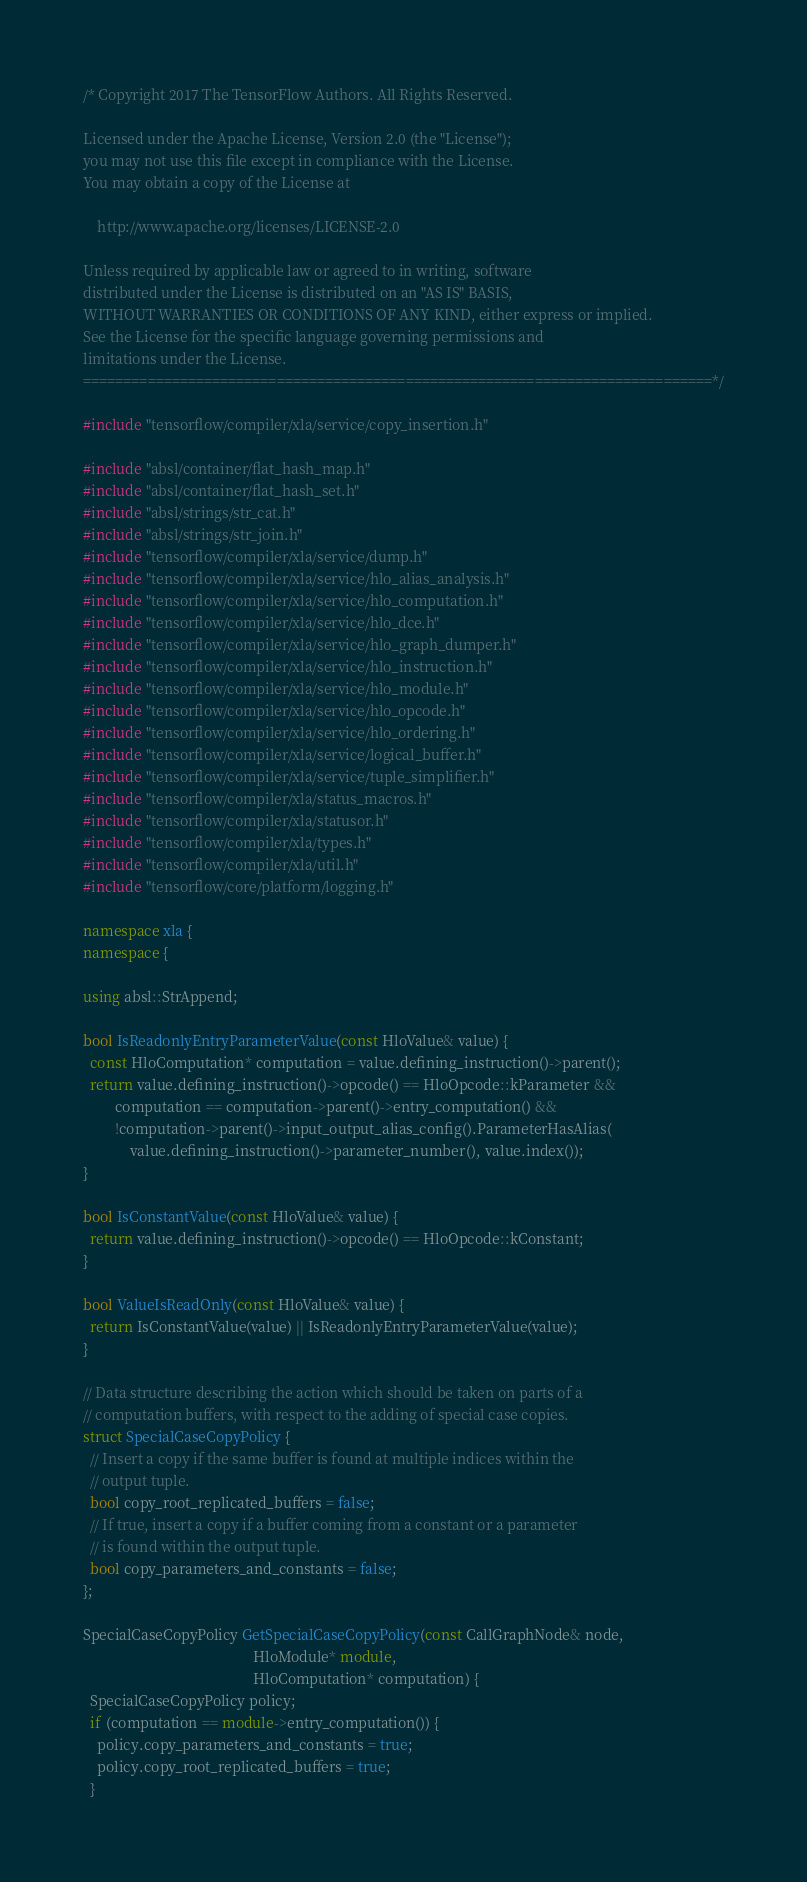<code> <loc_0><loc_0><loc_500><loc_500><_C++_>/* Copyright 2017 The TensorFlow Authors. All Rights Reserved.

Licensed under the Apache License, Version 2.0 (the "License");
you may not use this file except in compliance with the License.
You may obtain a copy of the License at

    http://www.apache.org/licenses/LICENSE-2.0

Unless required by applicable law or agreed to in writing, software
distributed under the License is distributed on an "AS IS" BASIS,
WITHOUT WARRANTIES OR CONDITIONS OF ANY KIND, either express or implied.
See the License for the specific language governing permissions and
limitations under the License.
==============================================================================*/

#include "tensorflow/compiler/xla/service/copy_insertion.h"

#include "absl/container/flat_hash_map.h"
#include "absl/container/flat_hash_set.h"
#include "absl/strings/str_cat.h"
#include "absl/strings/str_join.h"
#include "tensorflow/compiler/xla/service/dump.h"
#include "tensorflow/compiler/xla/service/hlo_alias_analysis.h"
#include "tensorflow/compiler/xla/service/hlo_computation.h"
#include "tensorflow/compiler/xla/service/hlo_dce.h"
#include "tensorflow/compiler/xla/service/hlo_graph_dumper.h"
#include "tensorflow/compiler/xla/service/hlo_instruction.h"
#include "tensorflow/compiler/xla/service/hlo_module.h"
#include "tensorflow/compiler/xla/service/hlo_opcode.h"
#include "tensorflow/compiler/xla/service/hlo_ordering.h"
#include "tensorflow/compiler/xla/service/logical_buffer.h"
#include "tensorflow/compiler/xla/service/tuple_simplifier.h"
#include "tensorflow/compiler/xla/status_macros.h"
#include "tensorflow/compiler/xla/statusor.h"
#include "tensorflow/compiler/xla/types.h"
#include "tensorflow/compiler/xla/util.h"
#include "tensorflow/core/platform/logging.h"

namespace xla {
namespace {

using absl::StrAppend;

bool IsReadonlyEntryParameterValue(const HloValue& value) {
  const HloComputation* computation = value.defining_instruction()->parent();
  return value.defining_instruction()->opcode() == HloOpcode::kParameter &&
         computation == computation->parent()->entry_computation() &&
         !computation->parent()->input_output_alias_config().ParameterHasAlias(
             value.defining_instruction()->parameter_number(), value.index());
}

bool IsConstantValue(const HloValue& value) {
  return value.defining_instruction()->opcode() == HloOpcode::kConstant;
}

bool ValueIsReadOnly(const HloValue& value) {
  return IsConstantValue(value) || IsReadonlyEntryParameterValue(value);
}

// Data structure describing the action which should be taken on parts of a
// computation buffers, with respect to the adding of special case copies.
struct SpecialCaseCopyPolicy {
  // Insert a copy if the same buffer is found at multiple indices within the
  // output tuple.
  bool copy_root_replicated_buffers = false;
  // If true, insert a copy if a buffer coming from a constant or a parameter
  // is found within the output tuple.
  bool copy_parameters_and_constants = false;
};

SpecialCaseCopyPolicy GetSpecialCaseCopyPolicy(const CallGraphNode& node,
                                               HloModule* module,
                                               HloComputation* computation) {
  SpecialCaseCopyPolicy policy;
  if (computation == module->entry_computation()) {
    policy.copy_parameters_and_constants = true;
    policy.copy_root_replicated_buffers = true;
  }</code> 